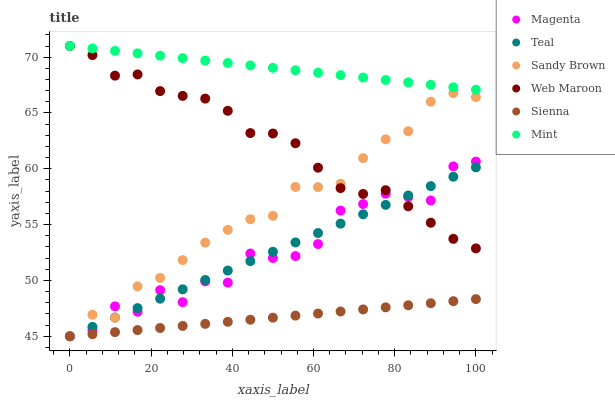Does Sienna have the minimum area under the curve?
Answer yes or no. Yes. Does Mint have the maximum area under the curve?
Answer yes or no. Yes. Does Web Maroon have the minimum area under the curve?
Answer yes or no. No. Does Web Maroon have the maximum area under the curve?
Answer yes or no. No. Is Sienna the smoothest?
Answer yes or no. Yes. Is Magenta the roughest?
Answer yes or no. Yes. Is Web Maroon the smoothest?
Answer yes or no. No. Is Web Maroon the roughest?
Answer yes or no. No. Does Sienna have the lowest value?
Answer yes or no. Yes. Does Web Maroon have the lowest value?
Answer yes or no. No. Does Web Maroon have the highest value?
Answer yes or no. Yes. Does Sienna have the highest value?
Answer yes or no. No. Is Sandy Brown less than Mint?
Answer yes or no. Yes. Is Mint greater than Teal?
Answer yes or no. Yes. Does Magenta intersect Sandy Brown?
Answer yes or no. Yes. Is Magenta less than Sandy Brown?
Answer yes or no. No. Is Magenta greater than Sandy Brown?
Answer yes or no. No. Does Sandy Brown intersect Mint?
Answer yes or no. No. 